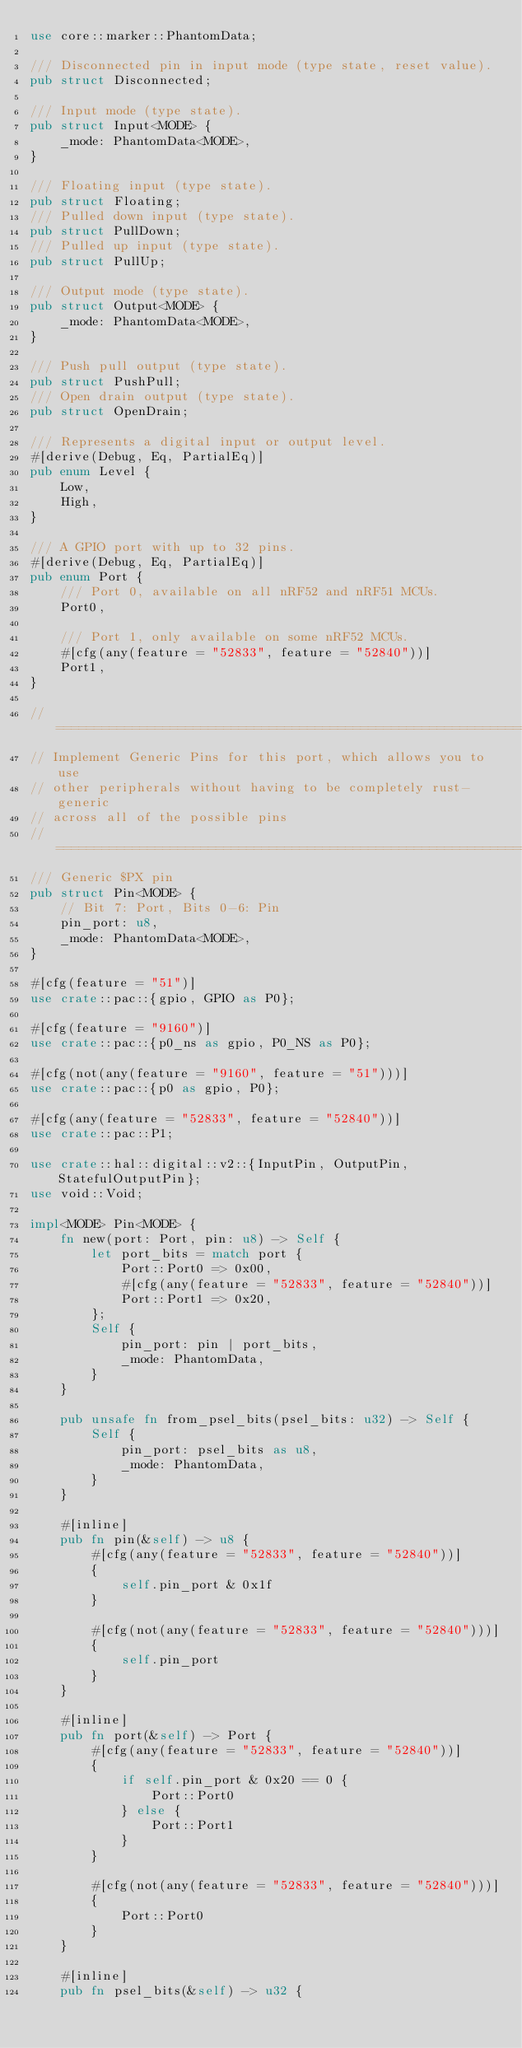<code> <loc_0><loc_0><loc_500><loc_500><_Rust_>use core::marker::PhantomData;

/// Disconnected pin in input mode (type state, reset value).
pub struct Disconnected;

/// Input mode (type state).
pub struct Input<MODE> {
    _mode: PhantomData<MODE>,
}

/// Floating input (type state).
pub struct Floating;
/// Pulled down input (type state).
pub struct PullDown;
/// Pulled up input (type state).
pub struct PullUp;

/// Output mode (type state).
pub struct Output<MODE> {
    _mode: PhantomData<MODE>,
}

/// Push pull output (type state).
pub struct PushPull;
/// Open drain output (type state).
pub struct OpenDrain;

/// Represents a digital input or output level.
#[derive(Debug, Eq, PartialEq)]
pub enum Level {
    Low,
    High,
}

/// A GPIO port with up to 32 pins.
#[derive(Debug, Eq, PartialEq)]
pub enum Port {
    /// Port 0, available on all nRF52 and nRF51 MCUs.
    Port0,

    /// Port 1, only available on some nRF52 MCUs.
    #[cfg(any(feature = "52833", feature = "52840"))]
    Port1,
}

// ===============================================================
// Implement Generic Pins for this port, which allows you to use
// other peripherals without having to be completely rust-generic
// across all of the possible pins
// ===============================================================
/// Generic $PX pin
pub struct Pin<MODE> {
    // Bit 7: Port, Bits 0-6: Pin
    pin_port: u8,
    _mode: PhantomData<MODE>,
}

#[cfg(feature = "51")]
use crate::pac::{gpio, GPIO as P0};

#[cfg(feature = "9160")]
use crate::pac::{p0_ns as gpio, P0_NS as P0};

#[cfg(not(any(feature = "9160", feature = "51")))]
use crate::pac::{p0 as gpio, P0};

#[cfg(any(feature = "52833", feature = "52840"))]
use crate::pac::P1;

use crate::hal::digital::v2::{InputPin, OutputPin, StatefulOutputPin};
use void::Void;

impl<MODE> Pin<MODE> {
    fn new(port: Port, pin: u8) -> Self {
        let port_bits = match port {
            Port::Port0 => 0x00,
            #[cfg(any(feature = "52833", feature = "52840"))]
            Port::Port1 => 0x20,
        };
        Self {
            pin_port: pin | port_bits,
            _mode: PhantomData,
        }
    }

    pub unsafe fn from_psel_bits(psel_bits: u32) -> Self {
        Self {
            pin_port: psel_bits as u8,
            _mode: PhantomData,
        }
    }

    #[inline]
    pub fn pin(&self) -> u8 {
        #[cfg(any(feature = "52833", feature = "52840"))]
        {
            self.pin_port & 0x1f
        }

        #[cfg(not(any(feature = "52833", feature = "52840")))]
        {
            self.pin_port
        }
    }

    #[inline]
    pub fn port(&self) -> Port {
        #[cfg(any(feature = "52833", feature = "52840"))]
        {
            if self.pin_port & 0x20 == 0 {
                Port::Port0
            } else {
                Port::Port1
            }
        }

        #[cfg(not(any(feature = "52833", feature = "52840")))]
        {
            Port::Port0
        }
    }

    #[inline]
    pub fn psel_bits(&self) -> u32 {</code> 